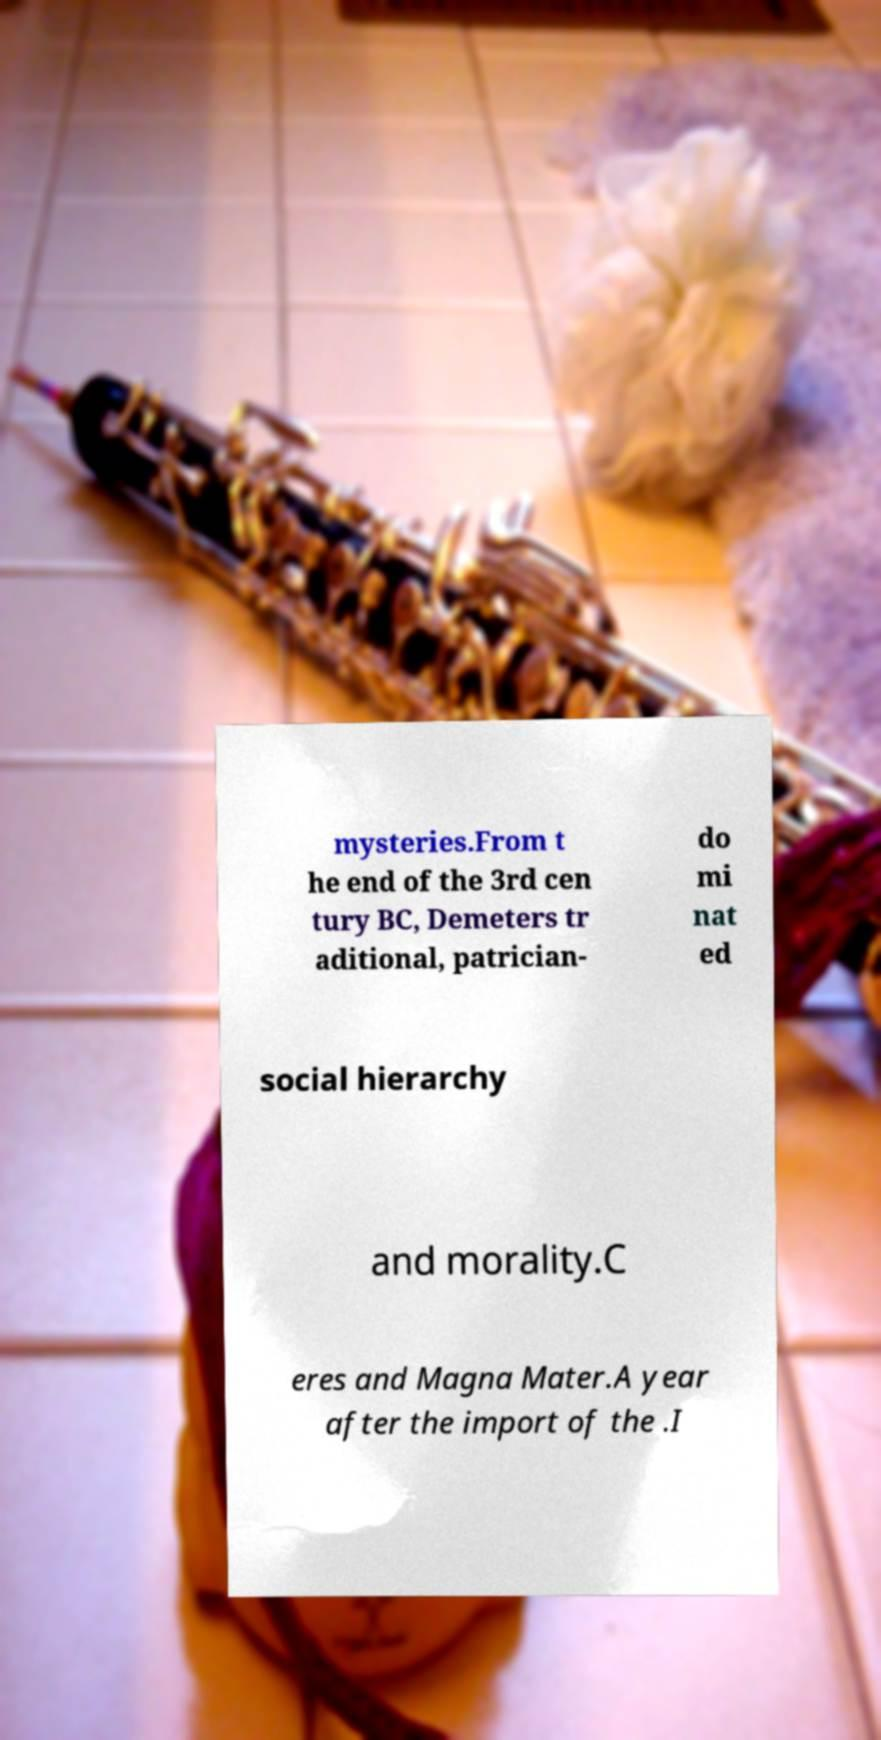Please identify and transcribe the text found in this image. mysteries.From t he end of the 3rd cen tury BC, Demeters tr aditional, patrician- do mi nat ed social hierarchy and morality.C eres and Magna Mater.A year after the import of the .I 